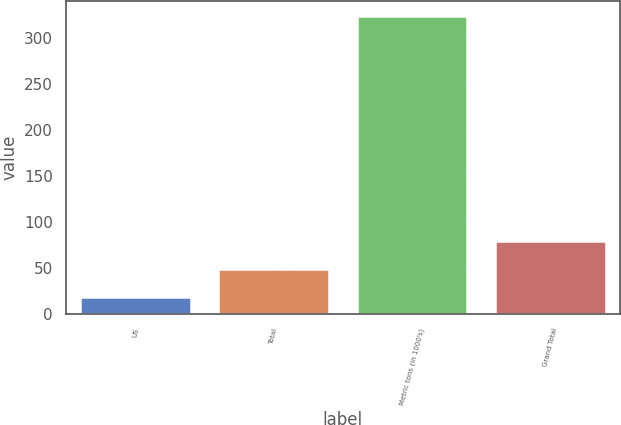Convert chart to OTSL. <chart><loc_0><loc_0><loc_500><loc_500><bar_chart><fcel>US<fcel>Total<fcel>Metric tons (in 1000's)<fcel>Grand Total<nl><fcel>19<fcel>49.5<fcel>324<fcel>80<nl></chart> 